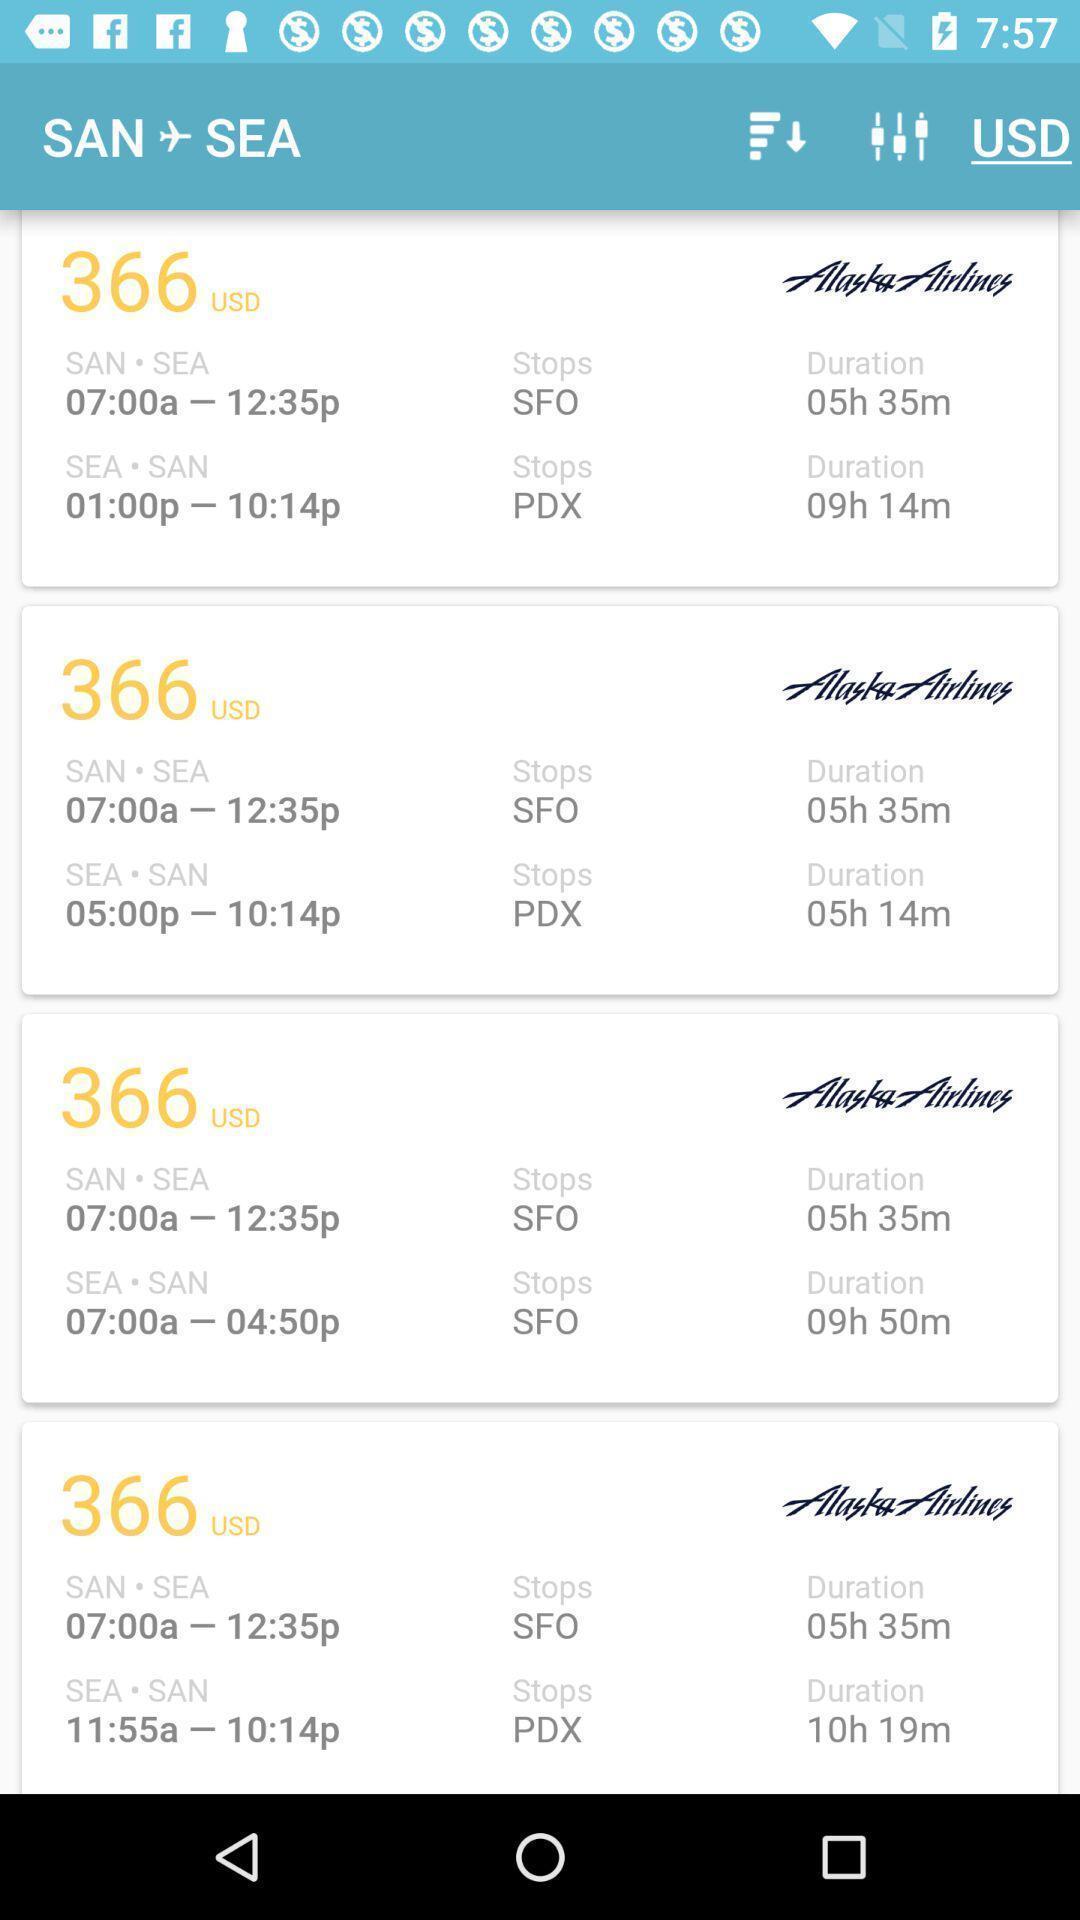Summarize the main components in this picture. Screen displaying list of flights details. 